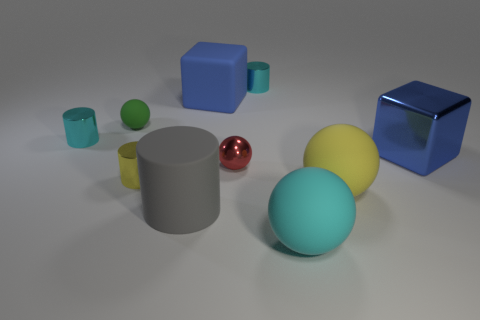Subtract all cubes. How many objects are left? 8 Add 7 small spheres. How many small spheres exist? 9 Subtract 0 purple spheres. How many objects are left? 10 Subtract all blue shiny cubes. Subtract all large blue matte blocks. How many objects are left? 8 Add 4 gray cylinders. How many gray cylinders are left? 5 